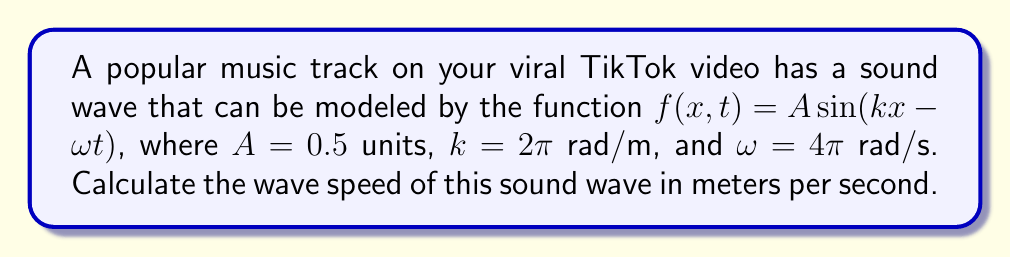Provide a solution to this math problem. To find the wave speed, we'll follow these steps:

1) The general form of a wave equation is:
   $$f(x,t) = A \sin(kx - \omega t)$$
   where:
   - $A$ is the amplitude
   - $k$ is the wave number
   - $\omega$ is the angular frequency

2) We're given:
   $A = 0.5$ units
   $k = 2\pi$ rad/m
   $\omega = 4\pi$ rad/s

3) The wave speed $v$ is related to $\omega$ and $k$ by the equation:
   $$v = \frac{\omega}{k}$$

4) Substituting the given values:
   $$v = \frac{4\pi}{2\pi} = 2$$

5) Therefore, the wave speed is 2 meters per second.
Answer: 2 m/s 